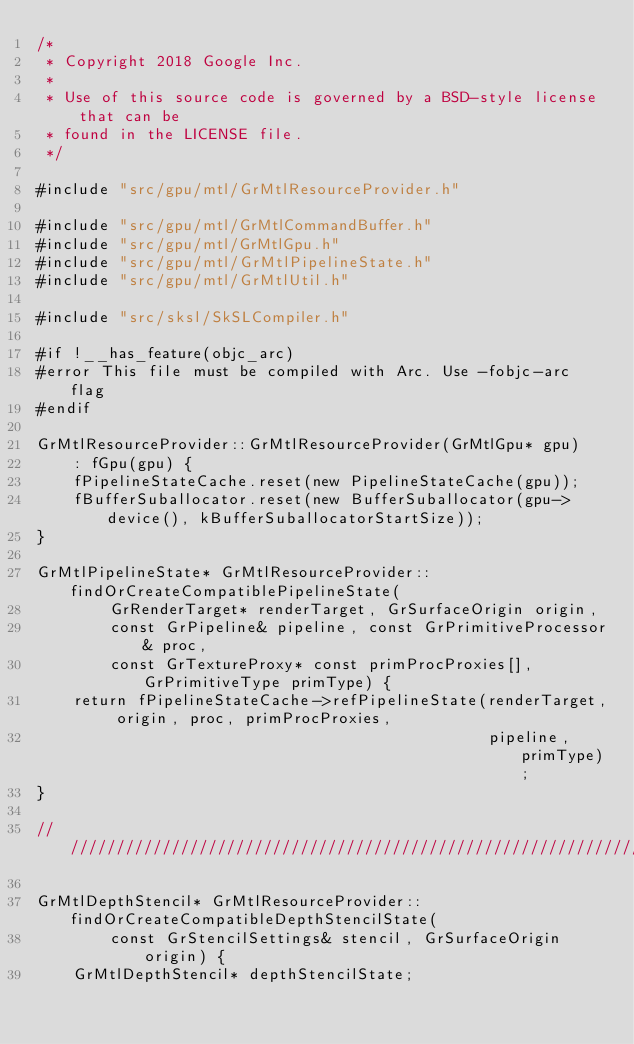Convert code to text. <code><loc_0><loc_0><loc_500><loc_500><_ObjectiveC_>/*
 * Copyright 2018 Google Inc.
 *
 * Use of this source code is governed by a BSD-style license that can be
 * found in the LICENSE file.
 */

#include "src/gpu/mtl/GrMtlResourceProvider.h"

#include "src/gpu/mtl/GrMtlCommandBuffer.h"
#include "src/gpu/mtl/GrMtlGpu.h"
#include "src/gpu/mtl/GrMtlPipelineState.h"
#include "src/gpu/mtl/GrMtlUtil.h"

#include "src/sksl/SkSLCompiler.h"

#if !__has_feature(objc_arc)
#error This file must be compiled with Arc. Use -fobjc-arc flag
#endif

GrMtlResourceProvider::GrMtlResourceProvider(GrMtlGpu* gpu)
    : fGpu(gpu) {
    fPipelineStateCache.reset(new PipelineStateCache(gpu));
    fBufferSuballocator.reset(new BufferSuballocator(gpu->device(), kBufferSuballocatorStartSize));
}

GrMtlPipelineState* GrMtlResourceProvider::findOrCreateCompatiblePipelineState(
        GrRenderTarget* renderTarget, GrSurfaceOrigin origin,
        const GrPipeline& pipeline, const GrPrimitiveProcessor& proc,
        const GrTextureProxy* const primProcProxies[], GrPrimitiveType primType) {
    return fPipelineStateCache->refPipelineState(renderTarget, origin, proc, primProcProxies,
                                                 pipeline, primType);
}

////////////////////////////////////////////////////////////////////////////////////////////////

GrMtlDepthStencil* GrMtlResourceProvider::findOrCreateCompatibleDepthStencilState(
        const GrStencilSettings& stencil, GrSurfaceOrigin origin) {
    GrMtlDepthStencil* depthStencilState;</code> 